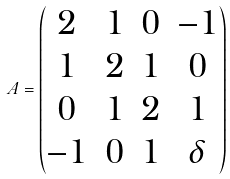<formula> <loc_0><loc_0><loc_500><loc_500>A = \begin{pmatrix} 2 & 1 & 0 & - 1 \\ 1 & 2 & 1 & 0 \\ 0 & 1 & 2 & 1 \\ - 1 & 0 & 1 & \delta \end{pmatrix}</formula> 